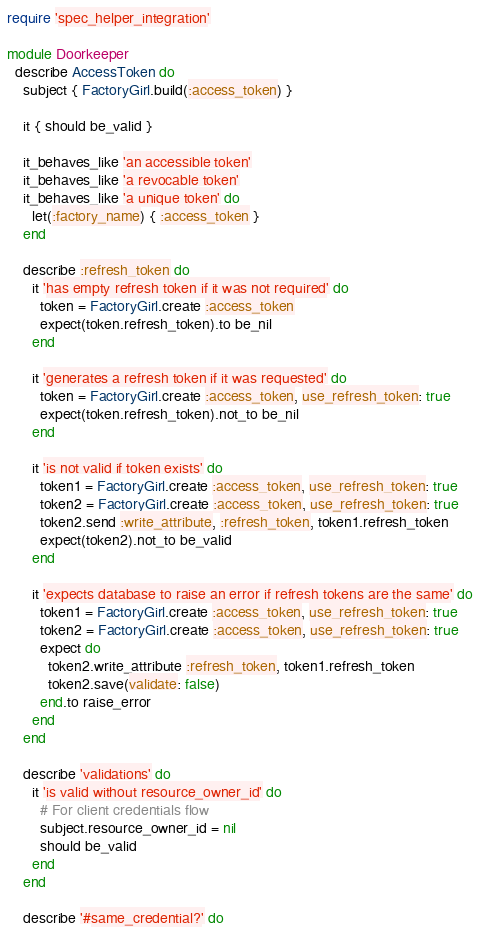Convert code to text. <code><loc_0><loc_0><loc_500><loc_500><_Ruby_>require 'spec_helper_integration'

module Doorkeeper
  describe AccessToken do
    subject { FactoryGirl.build(:access_token) }

    it { should be_valid }

    it_behaves_like 'an accessible token'
    it_behaves_like 'a revocable token'
    it_behaves_like 'a unique token' do
      let(:factory_name) { :access_token }
    end

    describe :refresh_token do
      it 'has empty refresh token if it was not required' do
        token = FactoryGirl.create :access_token
        expect(token.refresh_token).to be_nil
      end

      it 'generates a refresh token if it was requested' do
        token = FactoryGirl.create :access_token, use_refresh_token: true
        expect(token.refresh_token).not_to be_nil
      end

      it 'is not valid if token exists' do
        token1 = FactoryGirl.create :access_token, use_refresh_token: true
        token2 = FactoryGirl.create :access_token, use_refresh_token: true
        token2.send :write_attribute, :refresh_token, token1.refresh_token
        expect(token2).not_to be_valid
      end

      it 'expects database to raise an error if refresh tokens are the same' do
        token1 = FactoryGirl.create :access_token, use_refresh_token: true
        token2 = FactoryGirl.create :access_token, use_refresh_token: true
        expect do
          token2.write_attribute :refresh_token, token1.refresh_token
          token2.save(validate: false)
        end.to raise_error
      end
    end

    describe 'validations' do
      it 'is valid without resource_owner_id' do
        # For client credentials flow
        subject.resource_owner_id = nil
        should be_valid
      end
    end

    describe '#same_credential?' do
</code> 